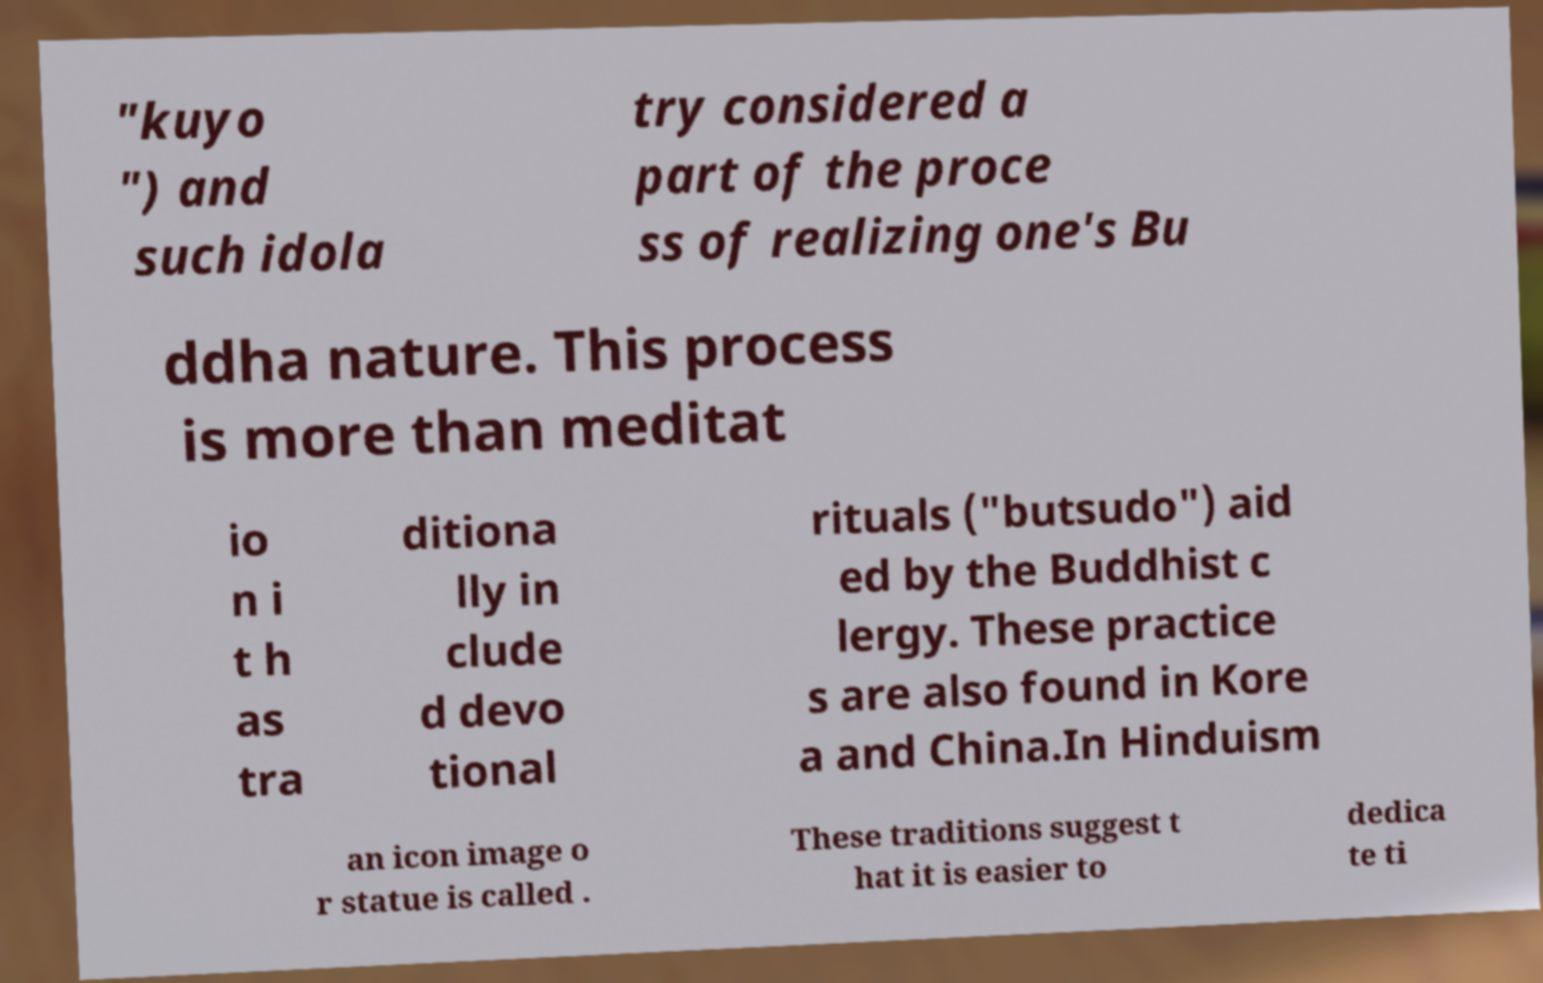What messages or text are displayed in this image? I need them in a readable, typed format. "kuyo ") and such idola try considered a part of the proce ss of realizing one's Bu ddha nature. This process is more than meditat io n i t h as tra ditiona lly in clude d devo tional rituals ("butsudo") aid ed by the Buddhist c lergy. These practice s are also found in Kore a and China.In Hinduism an icon image o r statue is called . These traditions suggest t hat it is easier to dedica te ti 